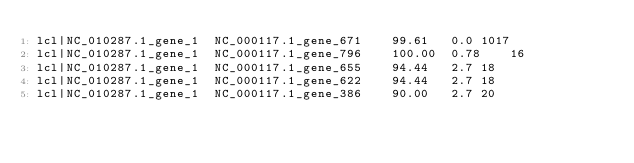Convert code to text. <code><loc_0><loc_0><loc_500><loc_500><_SQL_>lcl|NC_010287.1_gene_1	NC_000117.1_gene_671	99.61	0.0	1017
lcl|NC_010287.1_gene_1	NC_000117.1_gene_796	100.00	0.78	16
lcl|NC_010287.1_gene_1	NC_000117.1_gene_655	94.44	2.7	18
lcl|NC_010287.1_gene_1	NC_000117.1_gene_622	94.44	2.7	18
lcl|NC_010287.1_gene_1	NC_000117.1_gene_386	90.00	2.7	20</code> 